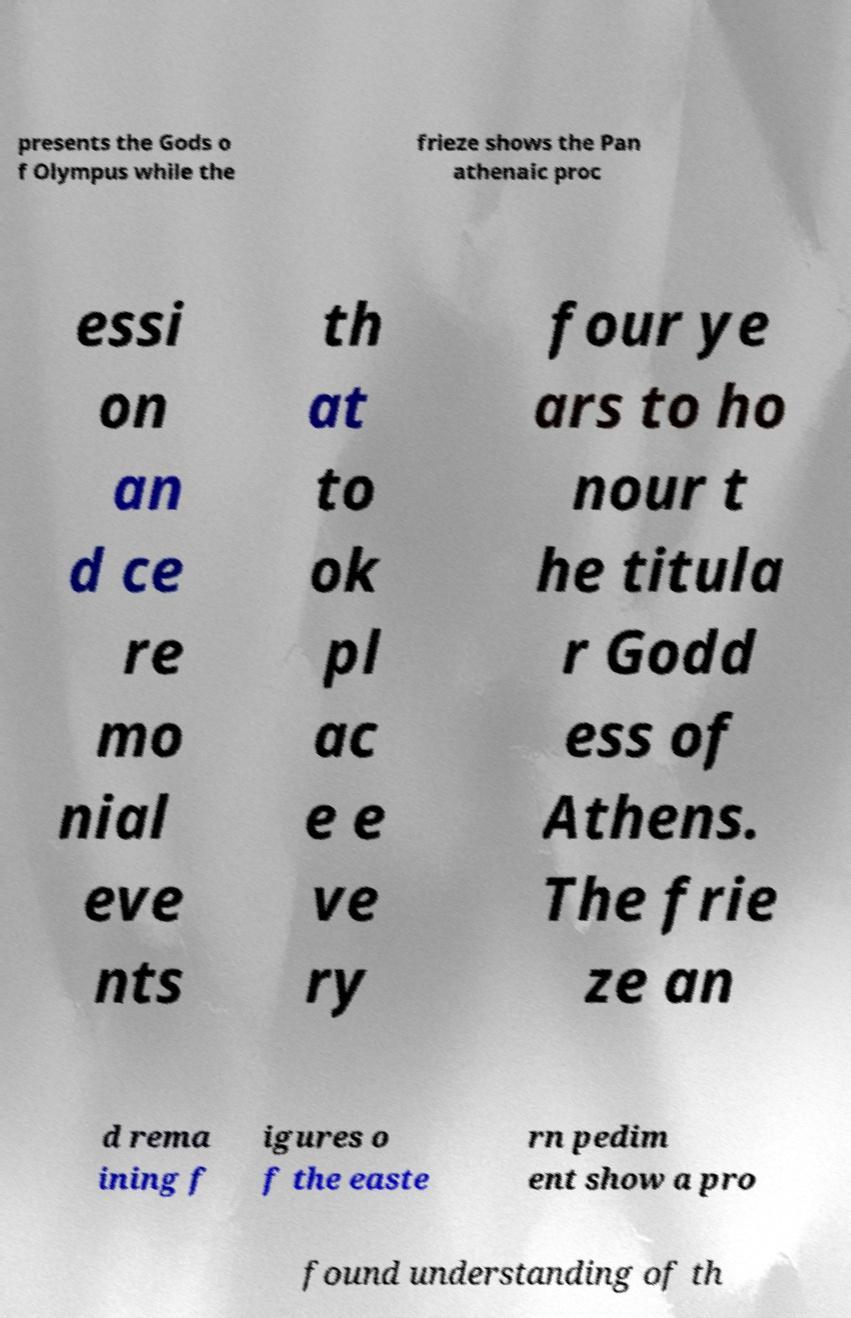I need the written content from this picture converted into text. Can you do that? presents the Gods o f Olympus while the frieze shows the Pan athenaic proc essi on an d ce re mo nial eve nts th at to ok pl ac e e ve ry four ye ars to ho nour t he titula r Godd ess of Athens. The frie ze an d rema ining f igures o f the easte rn pedim ent show a pro found understanding of th 